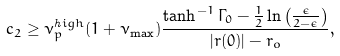<formula> <loc_0><loc_0><loc_500><loc_500>c _ { 2 } \geq \nu _ { p } ^ { \mathit h i g h } ( 1 + \nu _ { \mathit \max } ) \frac { \tanh ^ { - 1 } \Gamma _ { 0 } - \frac { 1 } { 2 } \ln \left ( \frac { \epsilon } { 2 - \epsilon } \right ) } { | { r } ( 0 ) | - r _ { o } } ,</formula> 